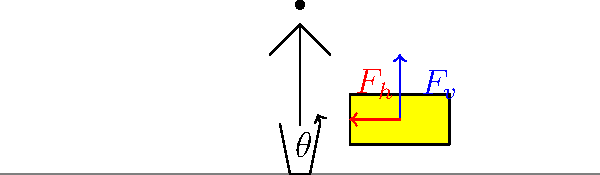When lifting a hay bale, you apply a vertical force $F_v = 200$ N and a horizontal force $F_h = 50$ N. If the angle between your arms and the ground is $\theta = 30°$, what is the magnitude of the total force $F_t$ applied to the hay bale? To find the magnitude of the total force applied to the hay bale, we need to use vector addition. Here's how we can solve this problem step-by-step:

1. Identify the given information:
   - Vertical force: $F_v = 200$ N
   - Horizontal force: $F_h = 50$ N
   - Angle between arms and ground: $\theta = 30°$

2. The total force $F_t$ is the vector sum of $F_v$ and $F_h$. We can use the Pythagorean theorem to calculate its magnitude:

   $F_t = \sqrt{F_v^2 + F_h^2}$

3. Substitute the given values:

   $F_t = \sqrt{(200 \text{ N})^2 + (50 \text{ N})^2}$

4. Calculate:

   $F_t = \sqrt{40,000 \text{ N}^2 + 2,500 \text{ N}^2}$
   $F_t = \sqrt{42,500 \text{ N}^2}$
   $F_t \approx 206.16 \text{ N}$

5. Round to two decimal places:

   $F_t \approx 206.16 \text{ N}$

This approach ensures proper posture and force distribution by considering both vertical and horizontal components of the lifting force.
Answer: 206.16 N 